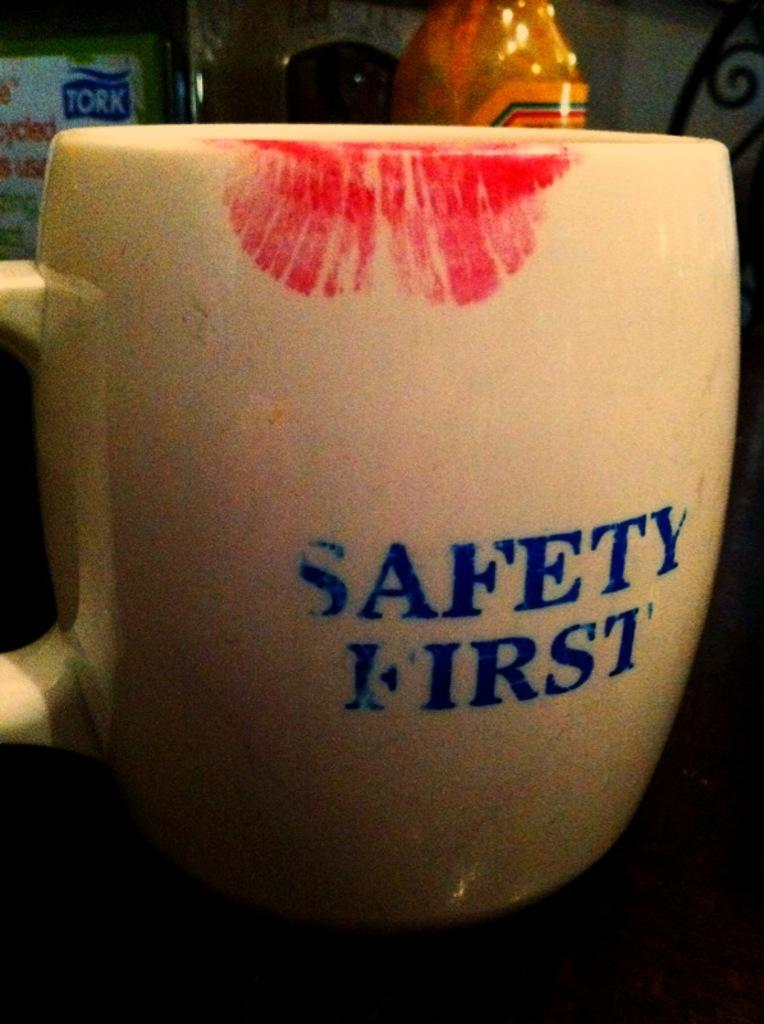<image>
Create a compact narrative representing the image presented. A coffee mug with safety first on its side. 